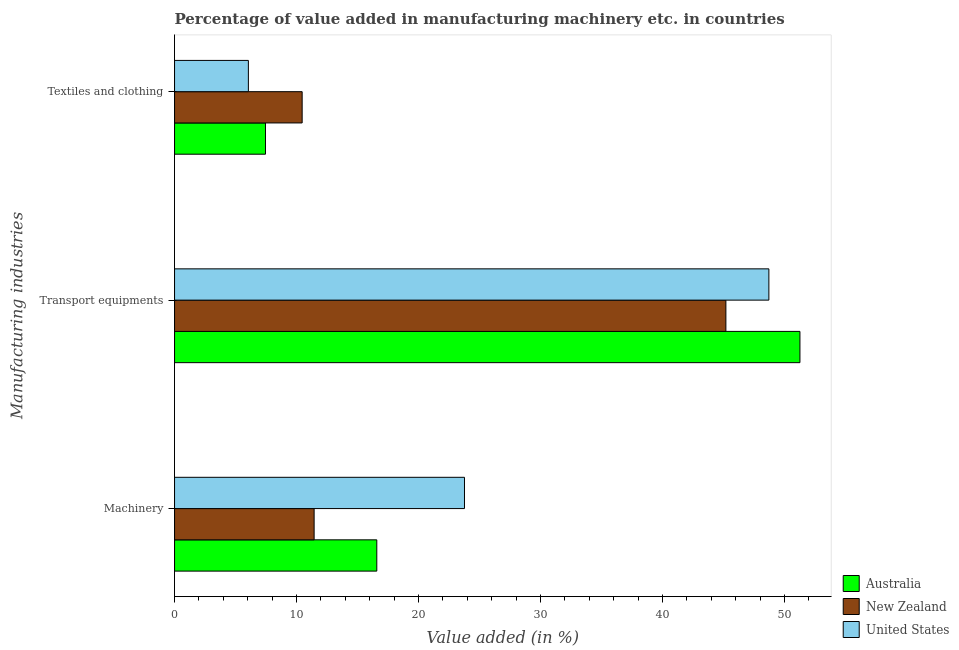How many groups of bars are there?
Your response must be concise. 3. Are the number of bars on each tick of the Y-axis equal?
Keep it short and to the point. Yes. How many bars are there on the 1st tick from the bottom?
Provide a short and direct response. 3. What is the label of the 2nd group of bars from the top?
Provide a short and direct response. Transport equipments. What is the value added in manufacturing transport equipments in New Zealand?
Ensure brevity in your answer.  45.2. Across all countries, what is the maximum value added in manufacturing machinery?
Provide a short and direct response. 23.77. Across all countries, what is the minimum value added in manufacturing transport equipments?
Ensure brevity in your answer.  45.2. In which country was the value added in manufacturing textile and clothing minimum?
Provide a short and direct response. United States. What is the total value added in manufacturing machinery in the graph?
Offer a terse response. 51.79. What is the difference between the value added in manufacturing textile and clothing in New Zealand and that in Australia?
Provide a succinct answer. 3.01. What is the difference between the value added in manufacturing transport equipments in Australia and the value added in manufacturing machinery in United States?
Your response must be concise. 27.5. What is the average value added in manufacturing transport equipments per country?
Provide a succinct answer. 48.39. What is the difference between the value added in manufacturing machinery and value added in manufacturing textile and clothing in United States?
Make the answer very short. 17.72. In how many countries, is the value added in manufacturing textile and clothing greater than 50 %?
Your answer should be compact. 0. What is the ratio of the value added in manufacturing textile and clothing in Australia to that in United States?
Offer a terse response. 1.23. Is the value added in manufacturing textile and clothing in Australia less than that in United States?
Offer a terse response. No. Is the difference between the value added in manufacturing textile and clothing in United States and New Zealand greater than the difference between the value added in manufacturing transport equipments in United States and New Zealand?
Your response must be concise. No. What is the difference between the highest and the second highest value added in manufacturing textile and clothing?
Make the answer very short. 3.01. What is the difference between the highest and the lowest value added in manufacturing transport equipments?
Your response must be concise. 6.07. What does the 3rd bar from the top in Transport equipments represents?
Make the answer very short. Australia. Is it the case that in every country, the sum of the value added in manufacturing machinery and value added in manufacturing transport equipments is greater than the value added in manufacturing textile and clothing?
Offer a terse response. Yes. How many countries are there in the graph?
Provide a short and direct response. 3. What is the difference between two consecutive major ticks on the X-axis?
Keep it short and to the point. 10. Are the values on the major ticks of X-axis written in scientific E-notation?
Your response must be concise. No. Does the graph contain grids?
Your answer should be very brief. No. How are the legend labels stacked?
Offer a very short reply. Vertical. What is the title of the graph?
Offer a very short reply. Percentage of value added in manufacturing machinery etc. in countries. Does "Antigua and Barbuda" appear as one of the legend labels in the graph?
Your answer should be compact. No. What is the label or title of the X-axis?
Your answer should be compact. Value added (in %). What is the label or title of the Y-axis?
Your answer should be very brief. Manufacturing industries. What is the Value added (in %) of Australia in Machinery?
Your answer should be very brief. 16.58. What is the Value added (in %) of New Zealand in Machinery?
Your answer should be compact. 11.44. What is the Value added (in %) in United States in Machinery?
Offer a very short reply. 23.77. What is the Value added (in %) in Australia in Transport equipments?
Keep it short and to the point. 51.27. What is the Value added (in %) of New Zealand in Transport equipments?
Make the answer very short. 45.2. What is the Value added (in %) of United States in Transport equipments?
Provide a short and direct response. 48.72. What is the Value added (in %) in Australia in Textiles and clothing?
Your response must be concise. 7.45. What is the Value added (in %) in New Zealand in Textiles and clothing?
Offer a very short reply. 10.46. What is the Value added (in %) of United States in Textiles and clothing?
Your answer should be compact. 6.05. Across all Manufacturing industries, what is the maximum Value added (in %) in Australia?
Ensure brevity in your answer.  51.27. Across all Manufacturing industries, what is the maximum Value added (in %) of New Zealand?
Ensure brevity in your answer.  45.2. Across all Manufacturing industries, what is the maximum Value added (in %) of United States?
Keep it short and to the point. 48.72. Across all Manufacturing industries, what is the minimum Value added (in %) of Australia?
Give a very brief answer. 7.45. Across all Manufacturing industries, what is the minimum Value added (in %) in New Zealand?
Make the answer very short. 10.46. Across all Manufacturing industries, what is the minimum Value added (in %) in United States?
Make the answer very short. 6.05. What is the total Value added (in %) in Australia in the graph?
Offer a terse response. 75.3. What is the total Value added (in %) in New Zealand in the graph?
Your answer should be very brief. 67.1. What is the total Value added (in %) of United States in the graph?
Your response must be concise. 78.54. What is the difference between the Value added (in %) of Australia in Machinery and that in Transport equipments?
Your response must be concise. -34.69. What is the difference between the Value added (in %) of New Zealand in Machinery and that in Transport equipments?
Give a very brief answer. -33.75. What is the difference between the Value added (in %) in United States in Machinery and that in Transport equipments?
Keep it short and to the point. -24.95. What is the difference between the Value added (in %) of Australia in Machinery and that in Textiles and clothing?
Your response must be concise. 9.12. What is the difference between the Value added (in %) in New Zealand in Machinery and that in Textiles and clothing?
Offer a very short reply. 0.98. What is the difference between the Value added (in %) of United States in Machinery and that in Textiles and clothing?
Your response must be concise. 17.72. What is the difference between the Value added (in %) of Australia in Transport equipments and that in Textiles and clothing?
Offer a terse response. 43.81. What is the difference between the Value added (in %) of New Zealand in Transport equipments and that in Textiles and clothing?
Keep it short and to the point. 34.74. What is the difference between the Value added (in %) in United States in Transport equipments and that in Textiles and clothing?
Provide a short and direct response. 42.67. What is the difference between the Value added (in %) in Australia in Machinery and the Value added (in %) in New Zealand in Transport equipments?
Your answer should be compact. -28.62. What is the difference between the Value added (in %) in Australia in Machinery and the Value added (in %) in United States in Transport equipments?
Give a very brief answer. -32.14. What is the difference between the Value added (in %) in New Zealand in Machinery and the Value added (in %) in United States in Transport equipments?
Your answer should be compact. -37.28. What is the difference between the Value added (in %) of Australia in Machinery and the Value added (in %) of New Zealand in Textiles and clothing?
Ensure brevity in your answer.  6.12. What is the difference between the Value added (in %) of Australia in Machinery and the Value added (in %) of United States in Textiles and clothing?
Give a very brief answer. 10.53. What is the difference between the Value added (in %) of New Zealand in Machinery and the Value added (in %) of United States in Textiles and clothing?
Give a very brief answer. 5.39. What is the difference between the Value added (in %) of Australia in Transport equipments and the Value added (in %) of New Zealand in Textiles and clothing?
Provide a short and direct response. 40.81. What is the difference between the Value added (in %) in Australia in Transport equipments and the Value added (in %) in United States in Textiles and clothing?
Give a very brief answer. 45.21. What is the difference between the Value added (in %) in New Zealand in Transport equipments and the Value added (in %) in United States in Textiles and clothing?
Offer a very short reply. 39.14. What is the average Value added (in %) in Australia per Manufacturing industries?
Make the answer very short. 25.1. What is the average Value added (in %) of New Zealand per Manufacturing industries?
Provide a succinct answer. 22.37. What is the average Value added (in %) in United States per Manufacturing industries?
Make the answer very short. 26.18. What is the difference between the Value added (in %) of Australia and Value added (in %) of New Zealand in Machinery?
Your answer should be compact. 5.14. What is the difference between the Value added (in %) in Australia and Value added (in %) in United States in Machinery?
Your response must be concise. -7.19. What is the difference between the Value added (in %) in New Zealand and Value added (in %) in United States in Machinery?
Provide a short and direct response. -12.33. What is the difference between the Value added (in %) in Australia and Value added (in %) in New Zealand in Transport equipments?
Ensure brevity in your answer.  6.07. What is the difference between the Value added (in %) of Australia and Value added (in %) of United States in Transport equipments?
Offer a very short reply. 2.55. What is the difference between the Value added (in %) of New Zealand and Value added (in %) of United States in Transport equipments?
Keep it short and to the point. -3.52. What is the difference between the Value added (in %) of Australia and Value added (in %) of New Zealand in Textiles and clothing?
Give a very brief answer. -3.01. What is the difference between the Value added (in %) of Australia and Value added (in %) of United States in Textiles and clothing?
Provide a succinct answer. 1.4. What is the difference between the Value added (in %) of New Zealand and Value added (in %) of United States in Textiles and clothing?
Offer a terse response. 4.41. What is the ratio of the Value added (in %) of Australia in Machinery to that in Transport equipments?
Provide a succinct answer. 0.32. What is the ratio of the Value added (in %) of New Zealand in Machinery to that in Transport equipments?
Provide a succinct answer. 0.25. What is the ratio of the Value added (in %) in United States in Machinery to that in Transport equipments?
Your answer should be compact. 0.49. What is the ratio of the Value added (in %) of Australia in Machinery to that in Textiles and clothing?
Provide a succinct answer. 2.22. What is the ratio of the Value added (in %) of New Zealand in Machinery to that in Textiles and clothing?
Ensure brevity in your answer.  1.09. What is the ratio of the Value added (in %) in United States in Machinery to that in Textiles and clothing?
Offer a terse response. 3.93. What is the ratio of the Value added (in %) in Australia in Transport equipments to that in Textiles and clothing?
Make the answer very short. 6.88. What is the ratio of the Value added (in %) in New Zealand in Transport equipments to that in Textiles and clothing?
Your response must be concise. 4.32. What is the ratio of the Value added (in %) in United States in Transport equipments to that in Textiles and clothing?
Provide a short and direct response. 8.05. What is the difference between the highest and the second highest Value added (in %) in Australia?
Ensure brevity in your answer.  34.69. What is the difference between the highest and the second highest Value added (in %) in New Zealand?
Your response must be concise. 33.75. What is the difference between the highest and the second highest Value added (in %) of United States?
Provide a short and direct response. 24.95. What is the difference between the highest and the lowest Value added (in %) in Australia?
Make the answer very short. 43.81. What is the difference between the highest and the lowest Value added (in %) of New Zealand?
Provide a short and direct response. 34.74. What is the difference between the highest and the lowest Value added (in %) of United States?
Make the answer very short. 42.67. 